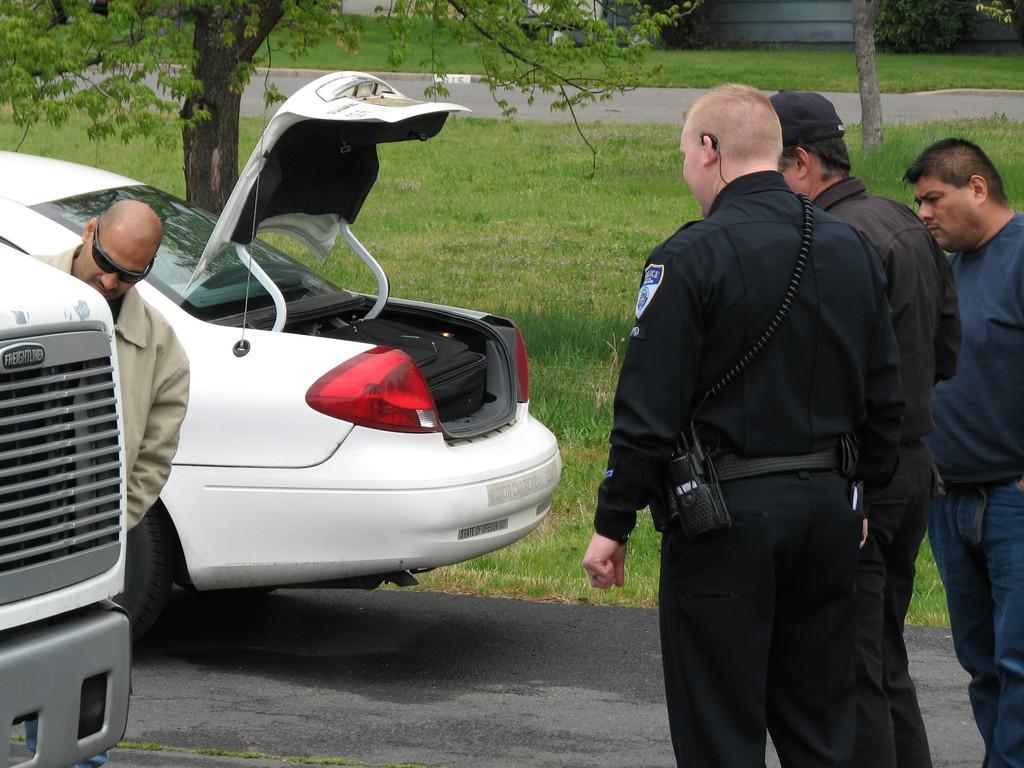Please provide a concise description of this image. In this image there are cars on a road and there are four men standing, in the background there is a greenland, trees. 